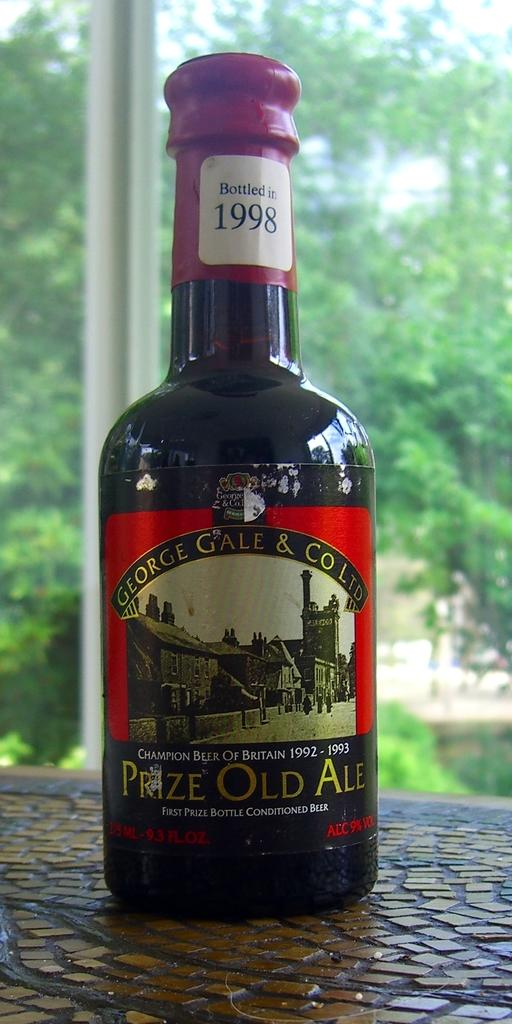Provide a one-sentence caption for the provided image. Bottle of beer with a label which syas "Prize Old Ale". 